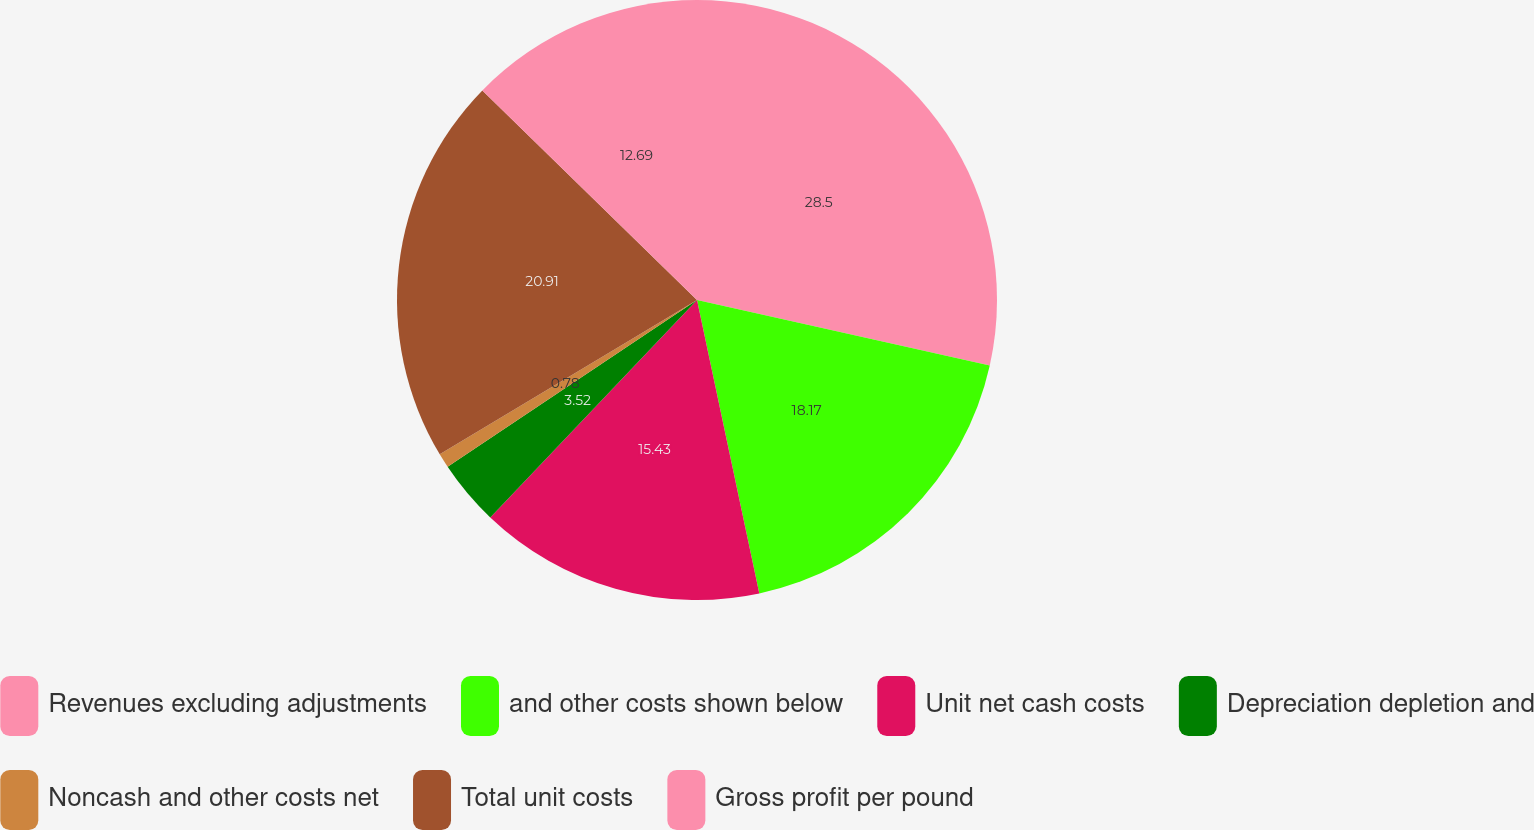<chart> <loc_0><loc_0><loc_500><loc_500><pie_chart><fcel>Revenues excluding adjustments<fcel>and other costs shown below<fcel>Unit net cash costs<fcel>Depreciation depletion and<fcel>Noncash and other costs net<fcel>Total unit costs<fcel>Gross profit per pound<nl><fcel>28.5%<fcel>18.17%<fcel>15.43%<fcel>3.52%<fcel>0.78%<fcel>20.91%<fcel>12.69%<nl></chart> 